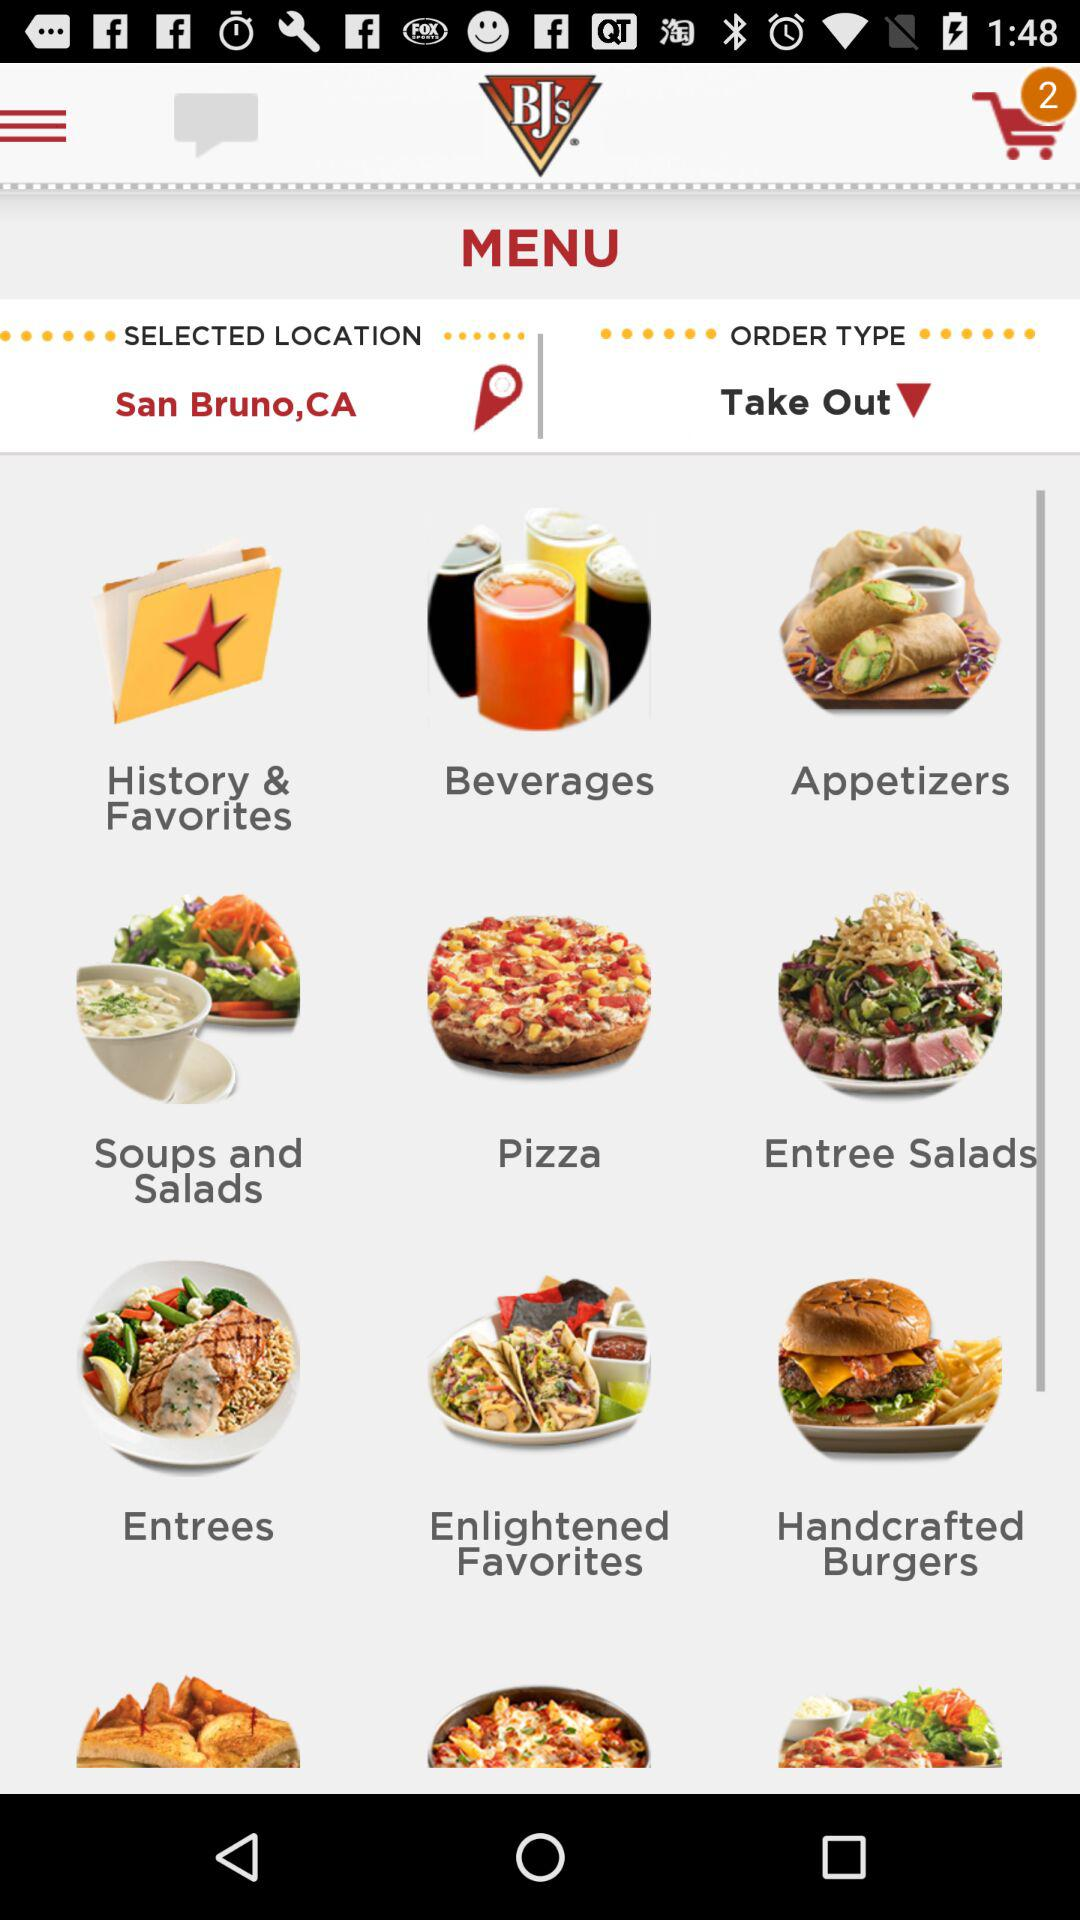What are the different food categories available in the menu? The different food categories available in the menu are "Beverages", "Appetizers", "Soups and Salads", "Pizza", "Entree Salads", "Entrees", "Enlightened Favorites" and "Handcrafted Burgers". 